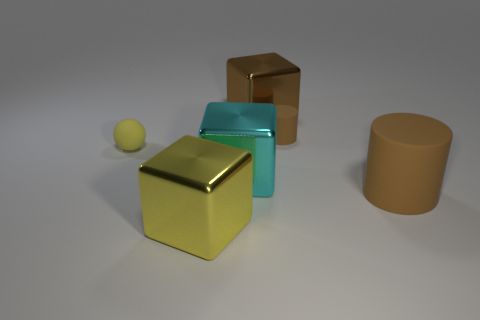Do the brown block and the rubber cylinder that is behind the tiny yellow matte thing have the same size?
Your response must be concise. No. How many other things are there of the same size as the brown shiny thing?
Your answer should be very brief. 3. What number of other things are the same color as the large cylinder?
Make the answer very short. 2. Is there any other thing that has the same size as the yellow cube?
Your answer should be compact. Yes. What number of other objects are the same shape as the big cyan metallic thing?
Your answer should be compact. 2. Is the size of the cyan cube the same as the brown metal cube?
Make the answer very short. Yes. Are there any metal things?
Provide a short and direct response. Yes. Is there any other thing that has the same material as the brown block?
Give a very brief answer. Yes. Is there a cyan thing that has the same material as the small yellow ball?
Make the answer very short. No. There is a yellow block that is the same size as the cyan metallic block; what is it made of?
Offer a terse response. Metal. 